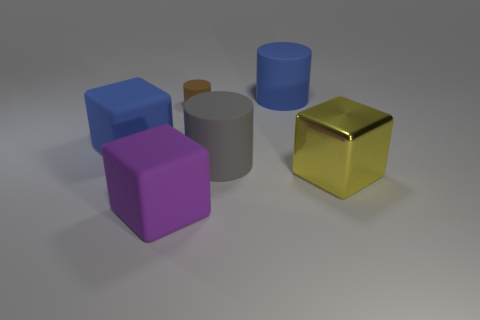Subtract all large rubber cubes. How many cubes are left? 1 Add 4 brown things. How many objects exist? 10 Subtract all purple objects. Subtract all big purple cylinders. How many objects are left? 5 Add 5 big gray rubber cylinders. How many big gray rubber cylinders are left? 6 Add 6 brown rubber objects. How many brown rubber objects exist? 7 Subtract 0 cyan cylinders. How many objects are left? 6 Subtract all red cylinders. Subtract all purple cubes. How many cylinders are left? 3 